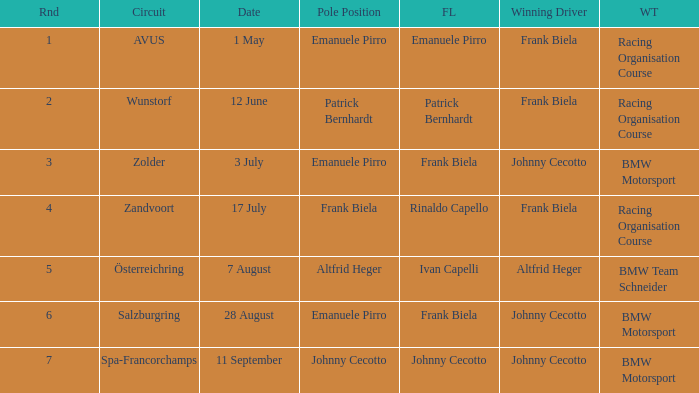What round was circuit Avus? 1.0. Give me the full table as a dictionary. {'header': ['Rnd', 'Circuit', 'Date', 'Pole Position', 'FL', 'Winning Driver', 'WT'], 'rows': [['1', 'AVUS', '1 May', 'Emanuele Pirro', 'Emanuele Pirro', 'Frank Biela', 'Racing Organisation Course'], ['2', 'Wunstorf', '12 June', 'Patrick Bernhardt', 'Patrick Bernhardt', 'Frank Biela', 'Racing Organisation Course'], ['3', 'Zolder', '3 July', 'Emanuele Pirro', 'Frank Biela', 'Johnny Cecotto', 'BMW Motorsport'], ['4', 'Zandvoort', '17 July', 'Frank Biela', 'Rinaldo Capello', 'Frank Biela', 'Racing Organisation Course'], ['5', 'Österreichring', '7 August', 'Altfrid Heger', 'Ivan Capelli', 'Altfrid Heger', 'BMW Team Schneider'], ['6', 'Salzburgring', '28 August', 'Emanuele Pirro', 'Frank Biela', 'Johnny Cecotto', 'BMW Motorsport'], ['7', 'Spa-Francorchamps', '11 September', 'Johnny Cecotto', 'Johnny Cecotto', 'Johnny Cecotto', 'BMW Motorsport']]} 